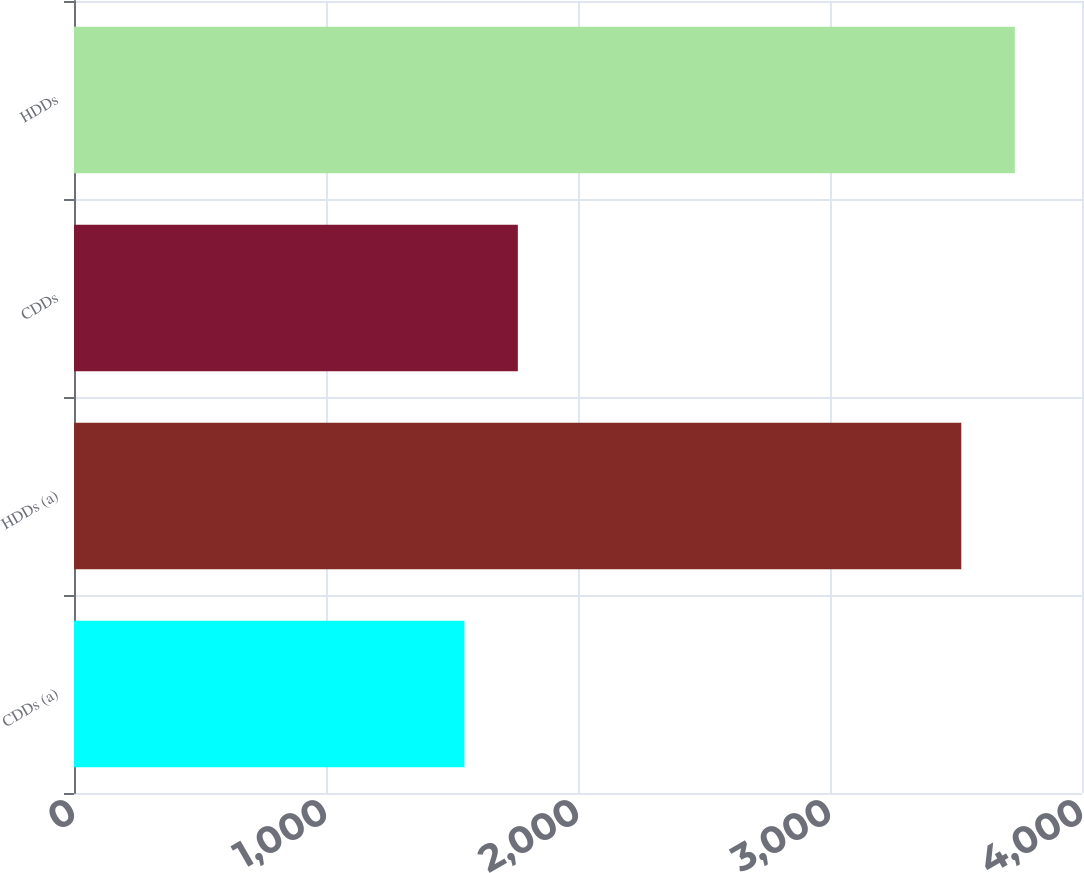Convert chart. <chart><loc_0><loc_0><loc_500><loc_500><bar_chart><fcel>CDDs (a)<fcel>HDDs (a)<fcel>CDDs<fcel>HDDs<nl><fcel>1549<fcel>3521<fcel>1761.3<fcel>3733.3<nl></chart> 